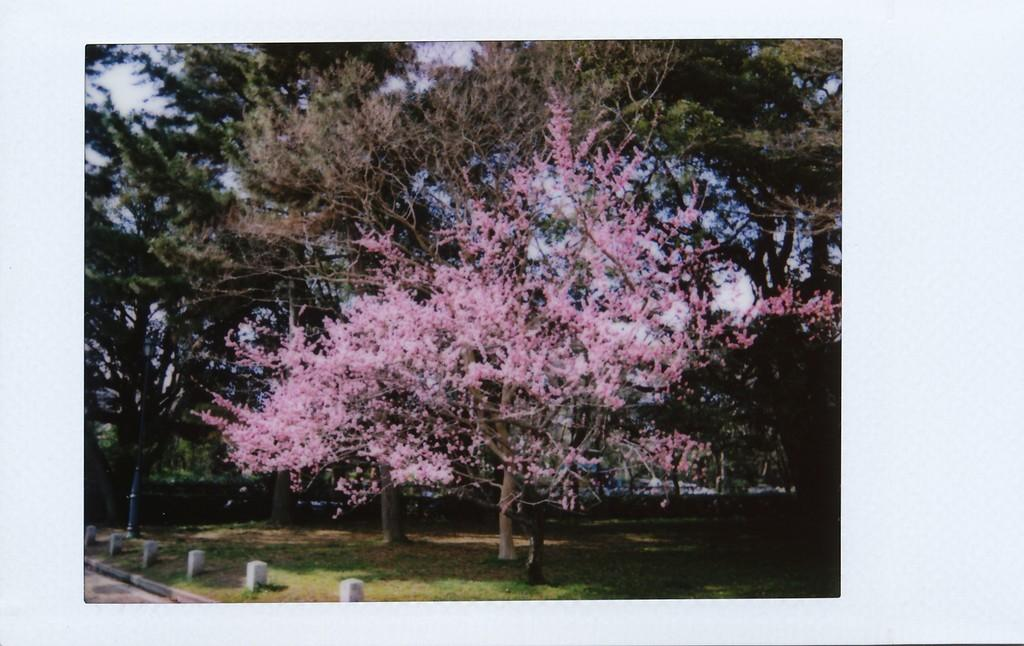How has the image been altered? The image is edited. What can be seen in the center of the image? There are trees in the center of the image. What objects are in the foreground of the image? There are poles and grass in the foreground of the image. What is the weather like in the image? It is sunny in the image. Where is the waste disposal area located in the image? There is no waste disposal area present in the image. What type of throne can be seen in the image? There is no throne present in the image. 